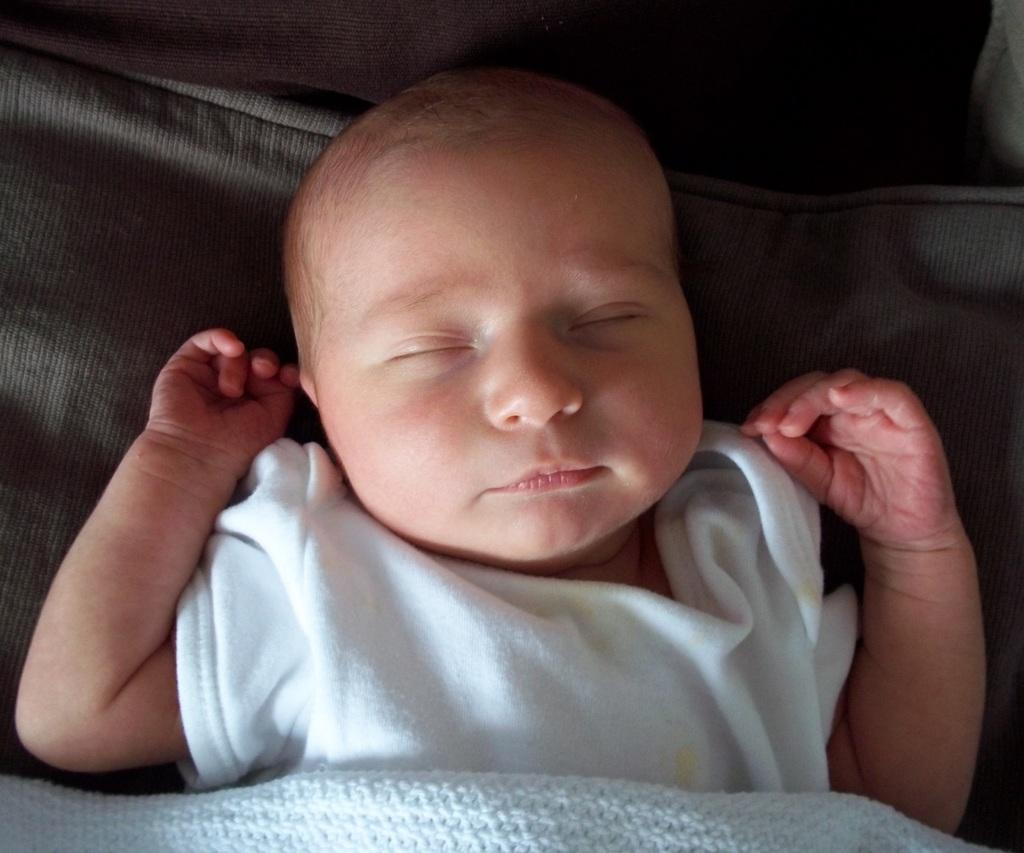What is the main subject of the image? There is a baby in the image. What is the baby wearing? The baby is wearing a white dress. Where is the baby located in the image? The baby is lying on a bed. What is covering the baby in the image? There is a white color blanket on the baby. What type of record is being played in the background of the image? There is no record being played in the background of the image; it only features a baby lying on a bed with a white blanket. 